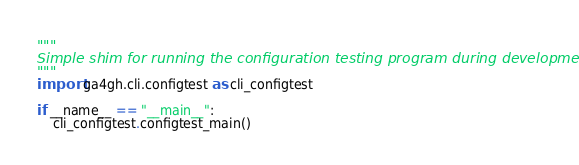Convert code to text. <code><loc_0><loc_0><loc_500><loc_500><_Python_>"""
Simple shim for running the configuration testing program during development.
"""
import ga4gh.cli.configtest as cli_configtest

if __name__ == "__main__":
    cli_configtest.configtest_main()
</code> 